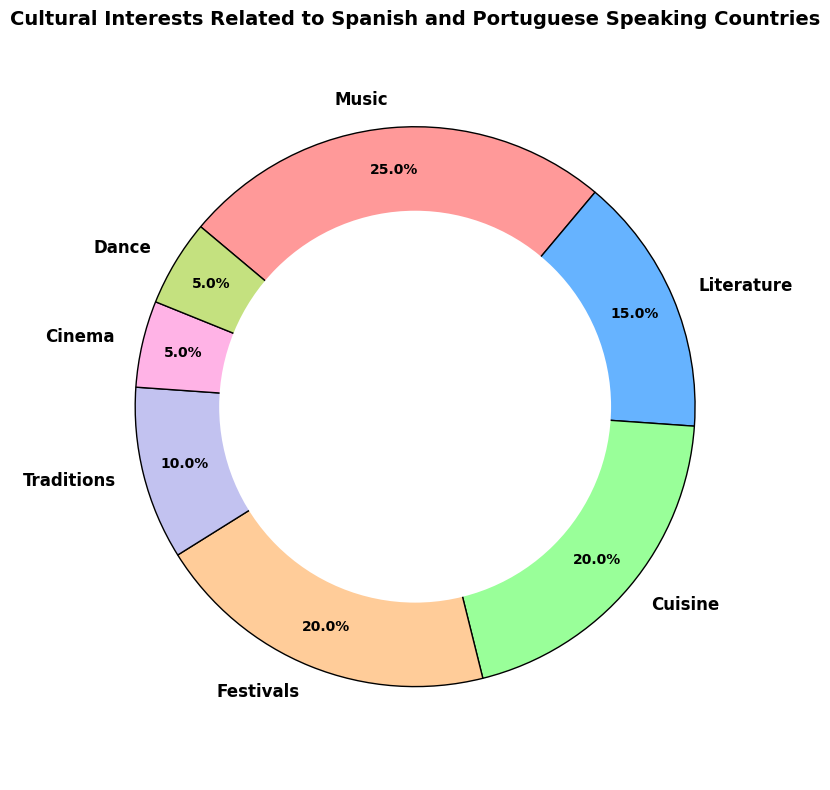what percentage of cultural interests is attributed to Cuisine and Festivals combined? Summing the percentages for Cuisine (20%) and Festivals (20%) gives a total of 20% + 20% = 40%.
Answer: 40% Which cultural aspect has the least interest and what is its percentage? The segment representing Cinema and Dance has the smallest size, indicating the least interest, both with 5%.
Answer: Cinema and Dance, 5% How does interest in Music compare to interest in Literature? The percentage for Music (25%) is higher than for Literature (15%).
Answer: Music is 10% higher than Literature Which category has the highest interest and what is the percentage? By looking at the largest pie segment, Music has the highest interest with 25%.
Answer: Music, 25% What’s the difference in interest between Cuisine and Traditions? Subtracting the percentage for Traditions (10%) from Cuisine (20%) gives 20% - 10% = 10%.
Answer: 10% What's the combined interest percentage of categories accounting for less than 10% each? Adding percentages for Cinema (5%) and Dance (5%) gives 5% + 5% = 10%.
Answer: 10% How does interest in Cuisine compare to interest in Traditions? The size of the pie segment for Cuisine (20%) is double that of Traditions (10%).
Answer: Cuisine is 10% higher than Traditions What's the combined percentage of Literature and Dance interests? Adding percentages for Literature (15%) and Dance (5%) gives 15% + 5% = 20%.
Answer: 20% Which categories together constitute 50% or more of the cultural interests? Summing Music (25%), Cuisine (20%), and Festivals (20%) results in 25% + 20% + 20% = 65%, which is more than 50%.
Answer: Music, Cuisine, Festivals 